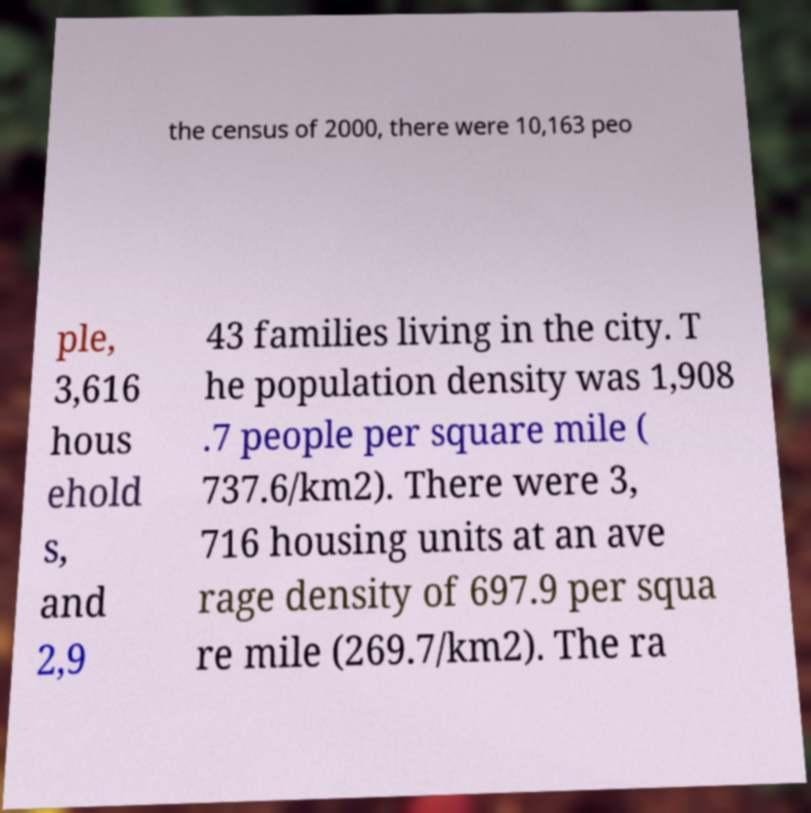I need the written content from this picture converted into text. Can you do that? the census of 2000, there were 10,163 peo ple, 3,616 hous ehold s, and 2,9 43 families living in the city. T he population density was 1,908 .7 people per square mile ( 737.6/km2). There were 3, 716 housing units at an ave rage density of 697.9 per squa re mile (269.7/km2). The ra 